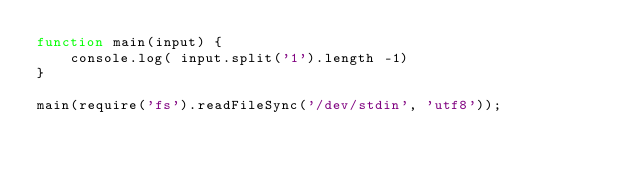Convert code to text. <code><loc_0><loc_0><loc_500><loc_500><_JavaScript_>function main(input) {
    console.log( input.split('1').length -1)
}

main(require('fs').readFileSync('/dev/stdin', 'utf8'));</code> 